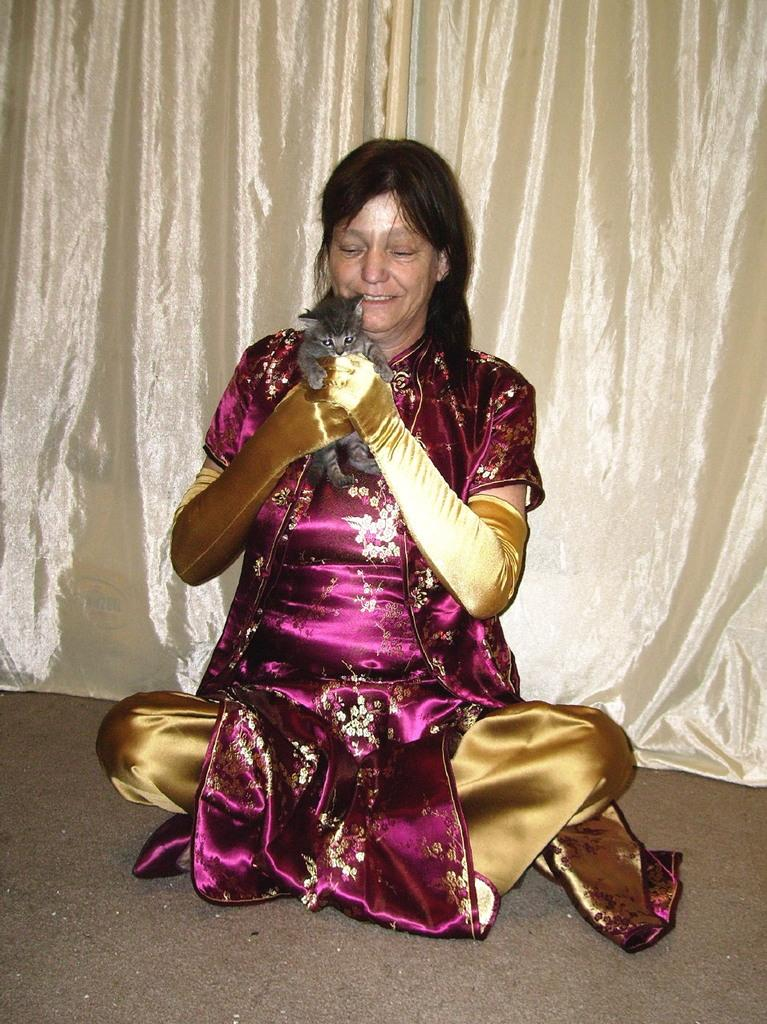Who is present in the image? There is a woman in the image. What is the woman doing in the image? The woman is sitting on the floor. What is the woman holding in her hand? The woman is holding a cat in her hand. What can be seen in the background of the image? There is a curtain visible in the image. What type of eggs can be seen in the image? There are no eggs present in the image. What hobbies does the woman have, as depicted in the image? The image does not provide information about the woman's hobbies. 